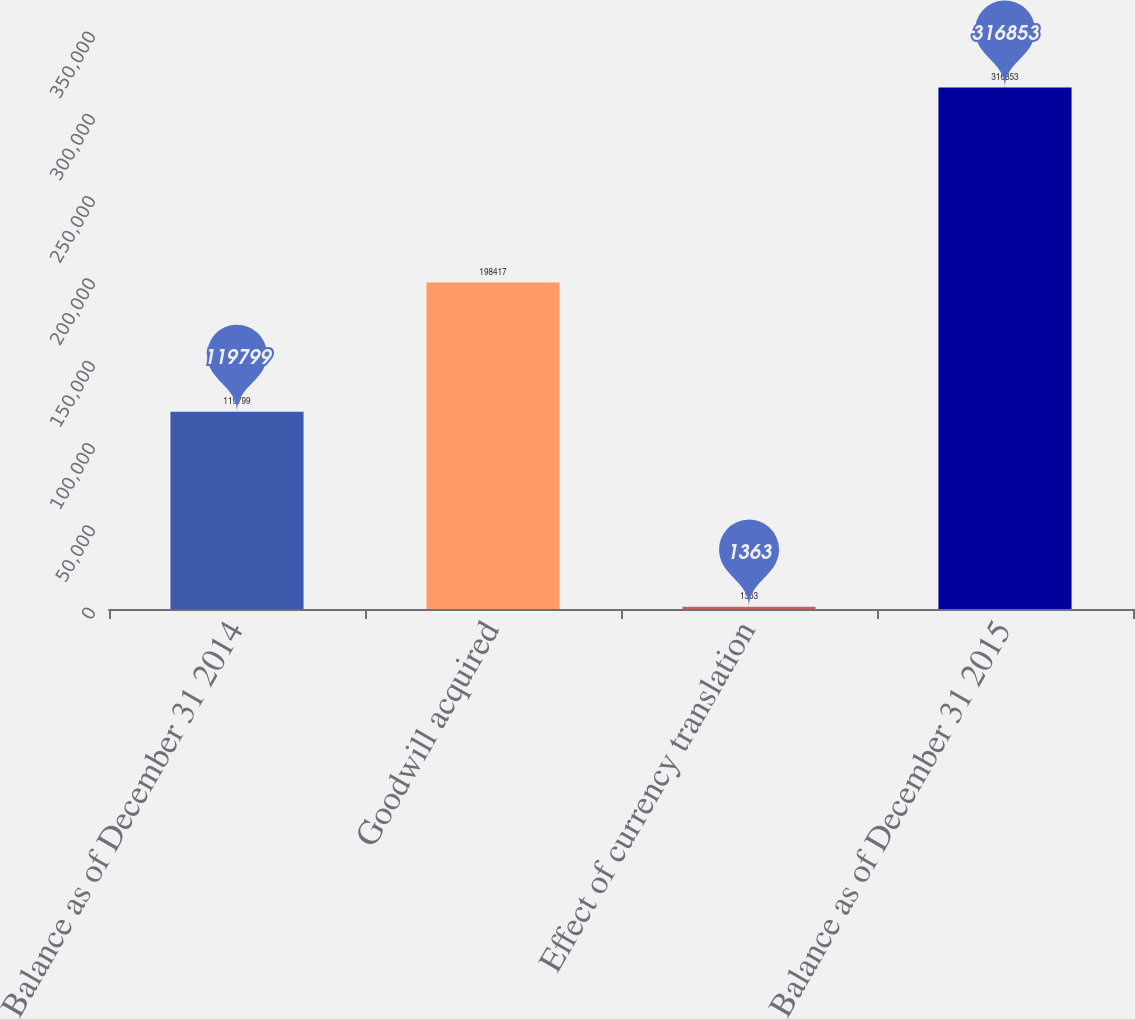<chart> <loc_0><loc_0><loc_500><loc_500><bar_chart><fcel>Balance as of December 31 2014<fcel>Goodwill acquired<fcel>Effect of currency translation<fcel>Balance as of December 31 2015<nl><fcel>119799<fcel>198417<fcel>1363<fcel>316853<nl></chart> 